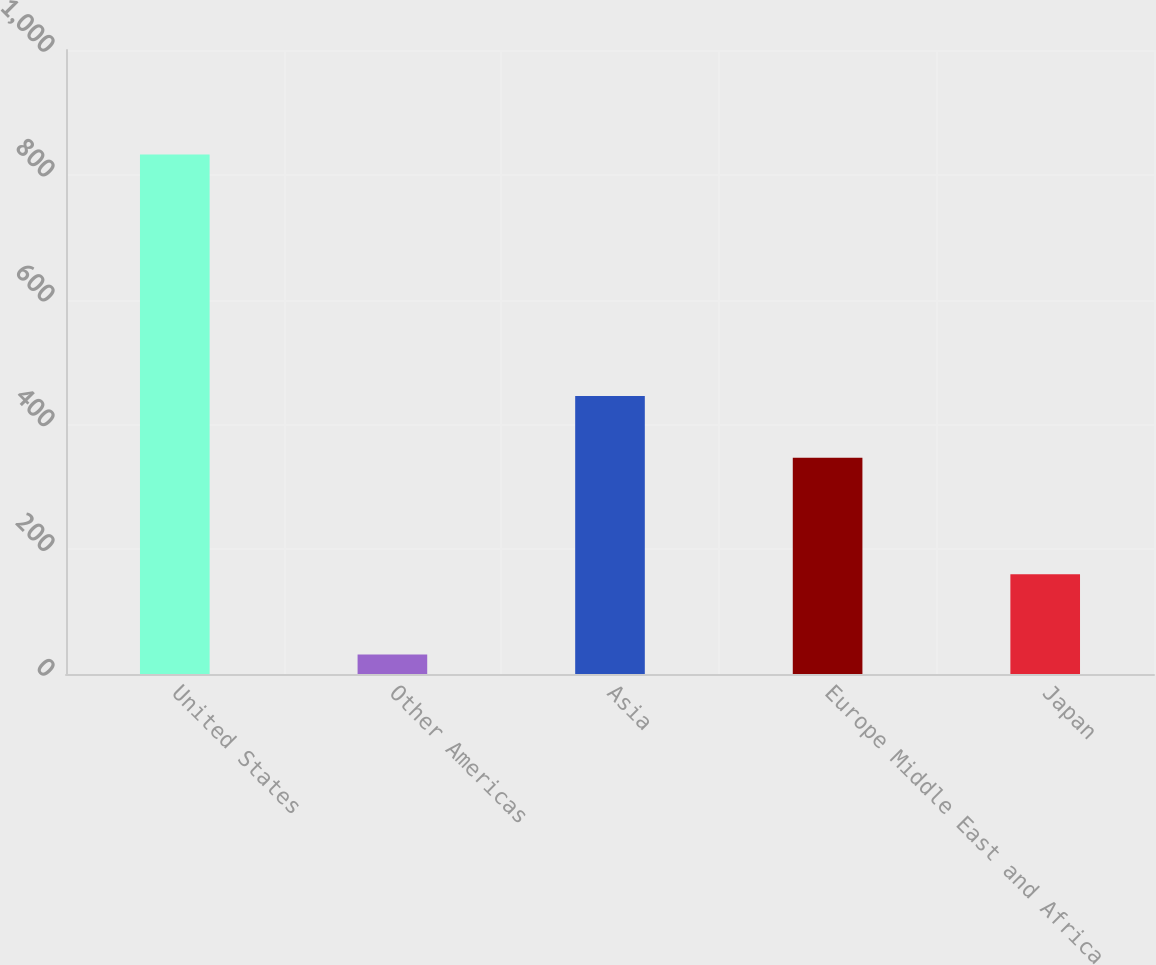Convert chart. <chart><loc_0><loc_0><loc_500><loc_500><bar_chart><fcel>United States<fcel>Other Americas<fcel>Asia<fcel>Europe Middle East and Africa<fcel>Japan<nl><fcel>832.6<fcel>31.3<fcel>445.5<fcel>346.7<fcel>160<nl></chart> 